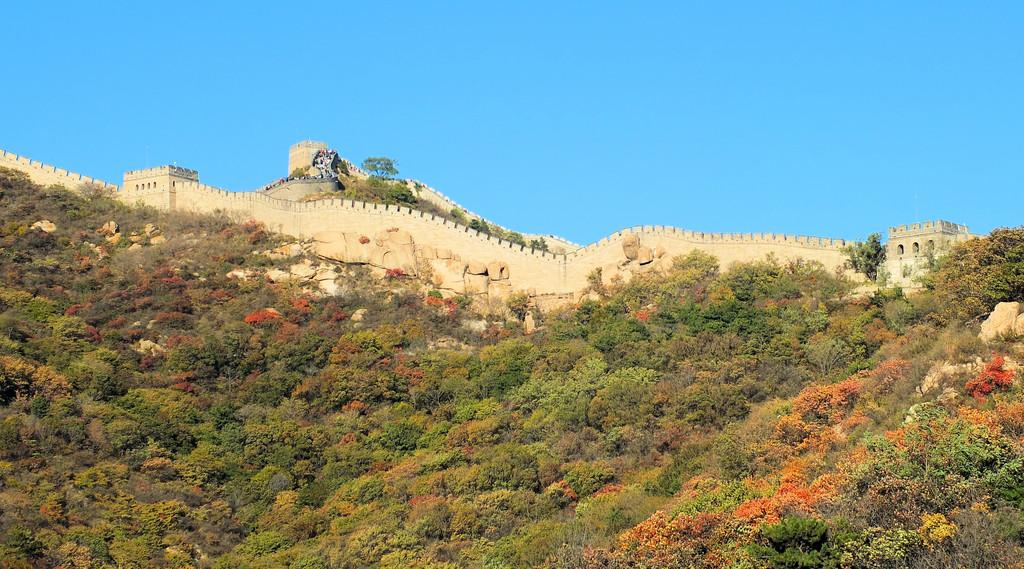What type of vegetation is present in the front of the image? There are trees and plants in the front of the image. What type of structure can be seen in the background of the image? There is a fort in the background of the image. What type of material is visible in the image? There are stones visible in the image. What type of authority does the dad have in the image? There is no dad present in the image, so it is not possible to determine the type of authority he might have. 